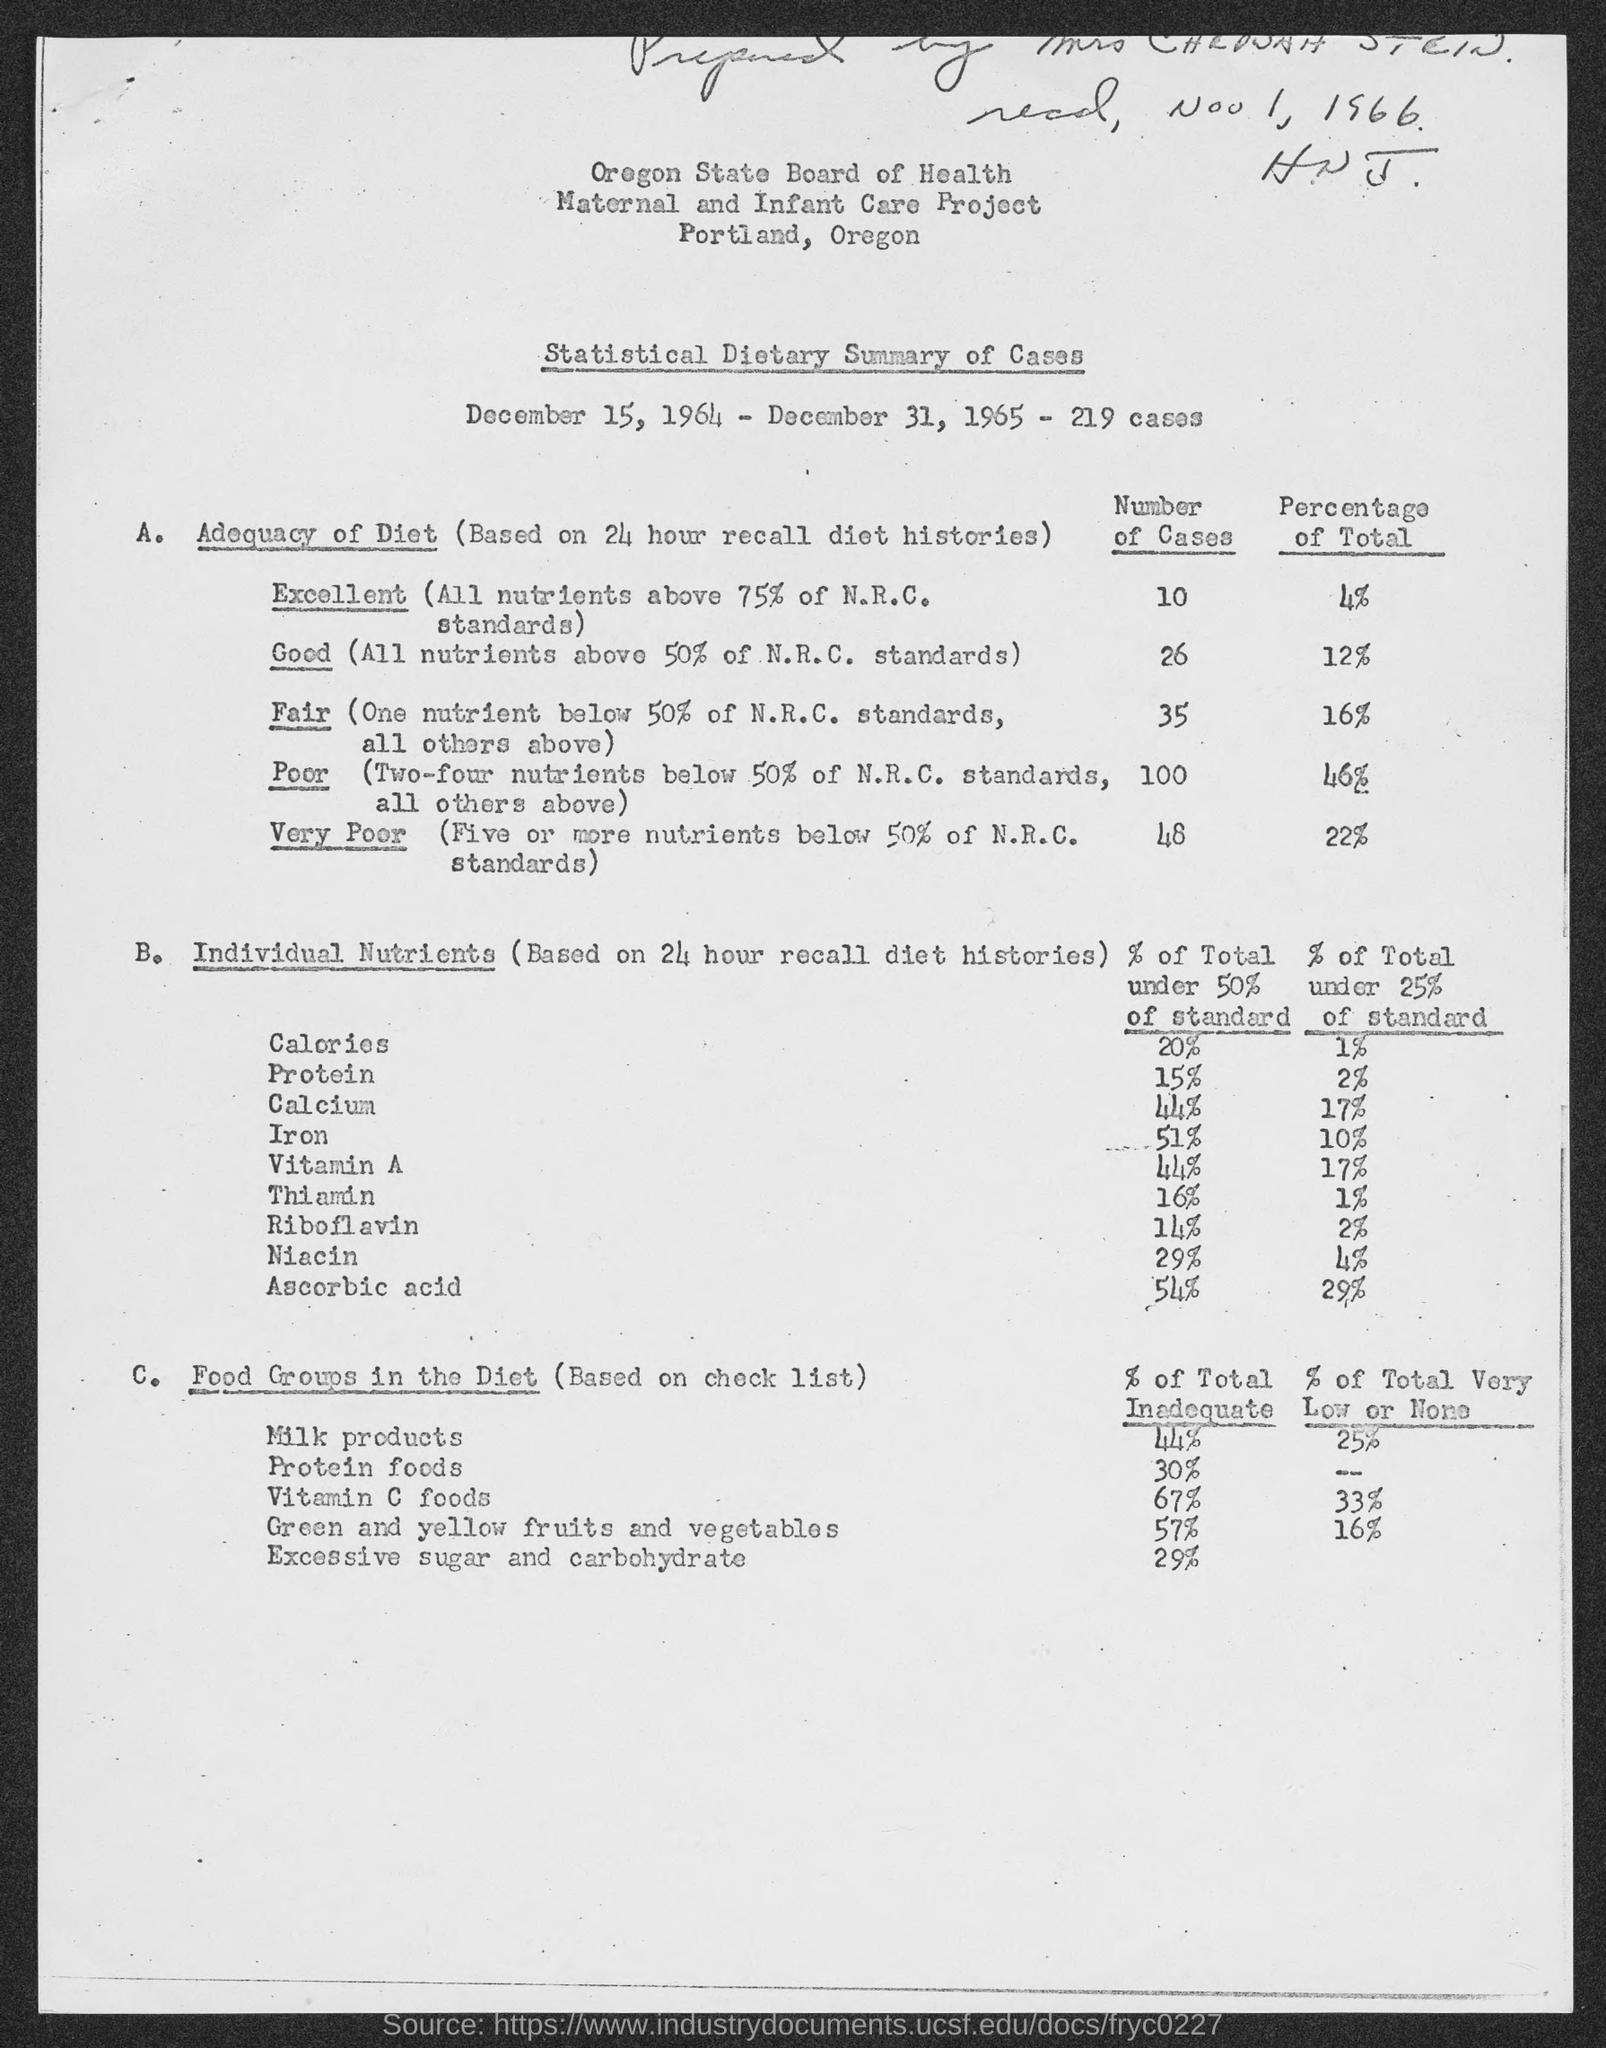How many cases were there from December 15, 1964 to December 31, 1965?
Your answer should be very brief. 219. How many cases were there with Excellent diet?
Your answer should be compact. 10. What is the calories percentage of total under 50% of standard
Give a very brief answer. 20. How much is the milk products percentage of total inadequate?
Provide a short and direct response. 44. 